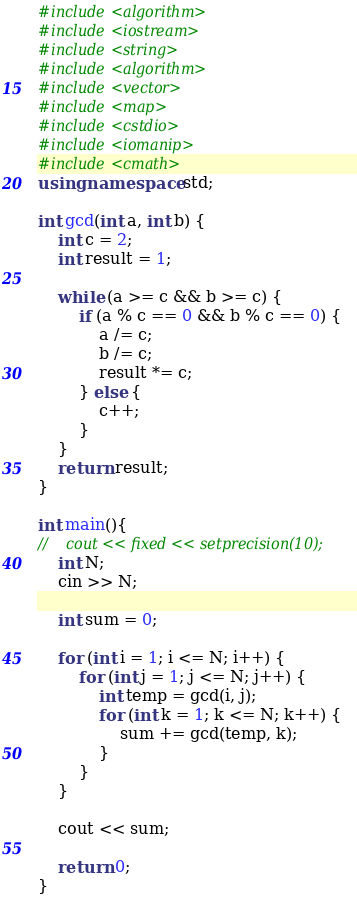Convert code to text. <code><loc_0><loc_0><loc_500><loc_500><_C++_>#include<algorithm>
#include<iostream>
#include<string>
#include<algorithm>
#include<vector>
#include<map>
#include<cstdio>
#include<iomanip>
#include<cmath>
using namespace std;

int gcd(int a, int b) {
    int c = 2;
    int result = 1;
    
    while (a >= c && b >= c) {
        if (a % c == 0 && b % c == 0) {
            a /= c;
            b /= c;
            result *= c;
        } else {
            c++;
        }
    }
    return result;
}

int main(){
//    cout << fixed << setprecision(10);
    int N;
    cin >> N;
    
    int sum = 0;
    
    for (int i = 1; i <= N; i++) {
        for (int j = 1; j <= N; j++) {
            int temp = gcd(i, j);
            for (int k = 1; k <= N; k++) {
                sum += gcd(temp, k);
            }
        }
    }
    
    cout << sum;

    return 0;
}
</code> 